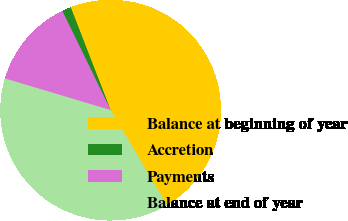Convert chart. <chart><loc_0><loc_0><loc_500><loc_500><pie_chart><fcel>Balance at beginning of year<fcel>Accretion<fcel>Payments<fcel>Balance at end of year<nl><fcel>47.37%<fcel>1.32%<fcel>13.16%<fcel>38.16%<nl></chart> 